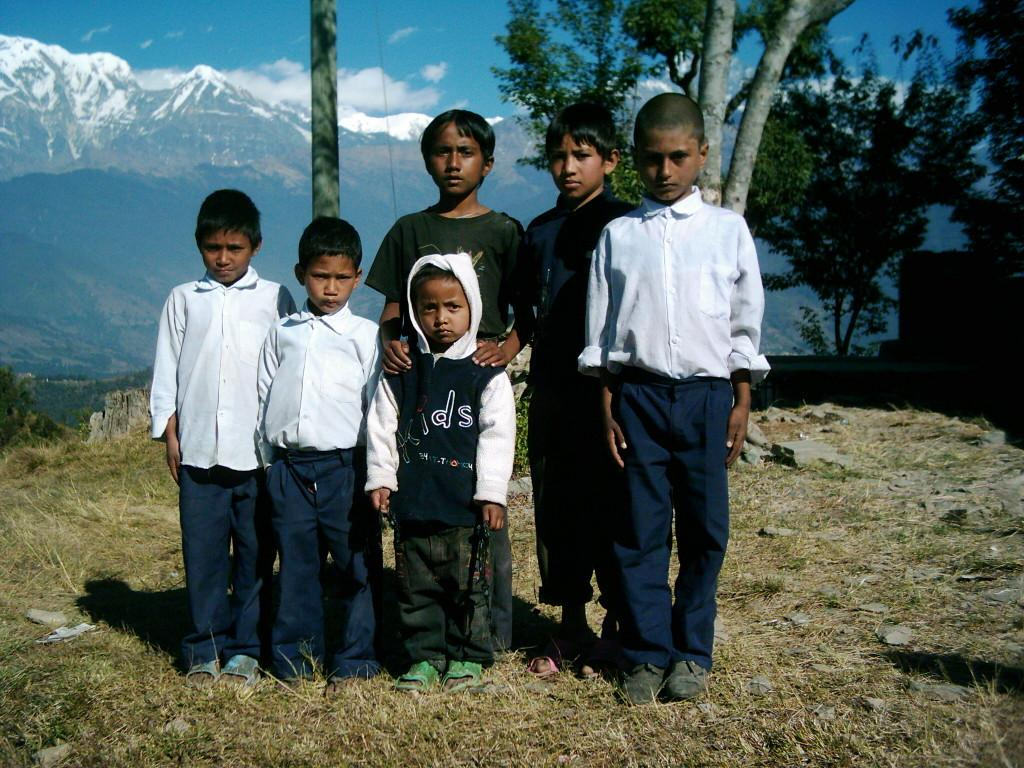Who is present in the image? There are children in the image. What type of surface is under the children's feet? There is grass on the ground in the image. What can be seen in the background of the image? There are trees in the image. What type of chalk is being used by the children in the image? There is no chalk present in the image. How deep is the hole that the children are digging in the image? There is no hole being dug in the image. 